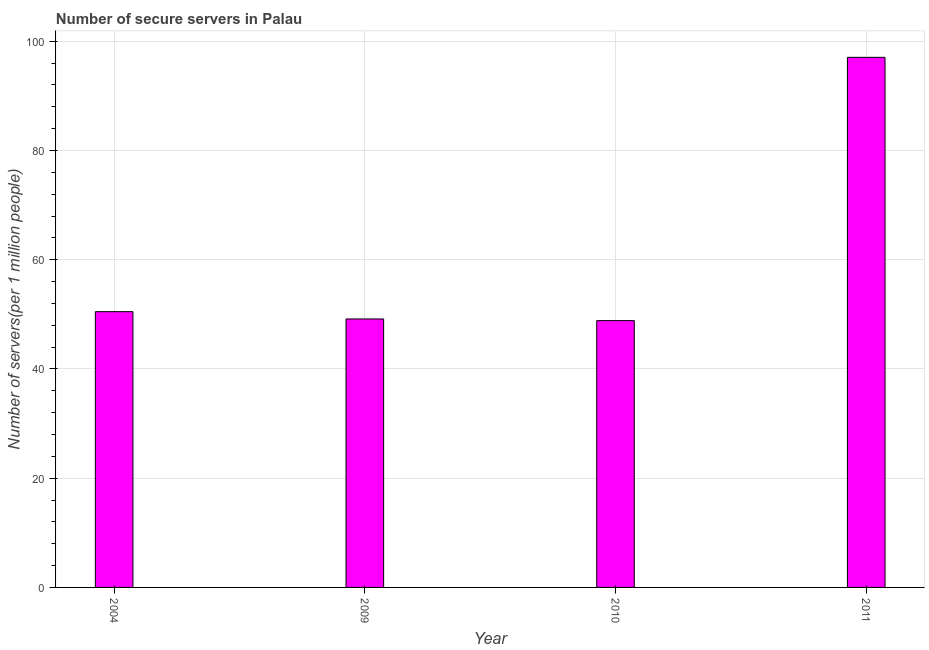What is the title of the graph?
Give a very brief answer. Number of secure servers in Palau. What is the label or title of the Y-axis?
Your response must be concise. Number of servers(per 1 million people). What is the number of secure internet servers in 2004?
Provide a succinct answer. 50.49. Across all years, what is the maximum number of secure internet servers?
Provide a short and direct response. 97.06. Across all years, what is the minimum number of secure internet servers?
Give a very brief answer. 48.85. In which year was the number of secure internet servers maximum?
Offer a terse response. 2011. In which year was the number of secure internet servers minimum?
Offer a very short reply. 2010. What is the sum of the number of secure internet servers?
Ensure brevity in your answer.  245.56. What is the difference between the number of secure internet servers in 2004 and 2009?
Keep it short and to the point. 1.34. What is the average number of secure internet servers per year?
Your answer should be compact. 61.39. What is the median number of secure internet servers?
Give a very brief answer. 49.82. In how many years, is the number of secure internet servers greater than 80 ?
Offer a terse response. 1. Do a majority of the years between 2011 and 2004 (inclusive) have number of secure internet servers greater than 12 ?
Provide a succinct answer. Yes. What is the ratio of the number of secure internet servers in 2009 to that in 2011?
Your answer should be compact. 0.51. Is the number of secure internet servers in 2009 less than that in 2010?
Provide a succinct answer. No. What is the difference between the highest and the second highest number of secure internet servers?
Make the answer very short. 46.57. What is the difference between the highest and the lowest number of secure internet servers?
Ensure brevity in your answer.  48.21. In how many years, is the number of secure internet servers greater than the average number of secure internet servers taken over all years?
Your answer should be very brief. 1. How many bars are there?
Provide a succinct answer. 4. How many years are there in the graph?
Your answer should be very brief. 4. Are the values on the major ticks of Y-axis written in scientific E-notation?
Offer a very short reply. No. What is the Number of servers(per 1 million people) in 2004?
Keep it short and to the point. 50.49. What is the Number of servers(per 1 million people) in 2009?
Offer a terse response. 49.15. What is the Number of servers(per 1 million people) in 2010?
Give a very brief answer. 48.85. What is the Number of servers(per 1 million people) in 2011?
Give a very brief answer. 97.06. What is the difference between the Number of servers(per 1 million people) in 2004 and 2009?
Make the answer very short. 1.34. What is the difference between the Number of servers(per 1 million people) in 2004 and 2010?
Provide a short and direct response. 1.64. What is the difference between the Number of servers(per 1 million people) in 2004 and 2011?
Your response must be concise. -46.57. What is the difference between the Number of servers(per 1 million people) in 2009 and 2010?
Ensure brevity in your answer.  0.3. What is the difference between the Number of servers(per 1 million people) in 2009 and 2011?
Provide a succinct answer. -47.9. What is the difference between the Number of servers(per 1 million people) in 2010 and 2011?
Provide a succinct answer. -48.21. What is the ratio of the Number of servers(per 1 million people) in 2004 to that in 2009?
Offer a terse response. 1.03. What is the ratio of the Number of servers(per 1 million people) in 2004 to that in 2010?
Offer a terse response. 1.03. What is the ratio of the Number of servers(per 1 million people) in 2004 to that in 2011?
Give a very brief answer. 0.52. What is the ratio of the Number of servers(per 1 million people) in 2009 to that in 2011?
Provide a short and direct response. 0.51. What is the ratio of the Number of servers(per 1 million people) in 2010 to that in 2011?
Provide a short and direct response. 0.5. 